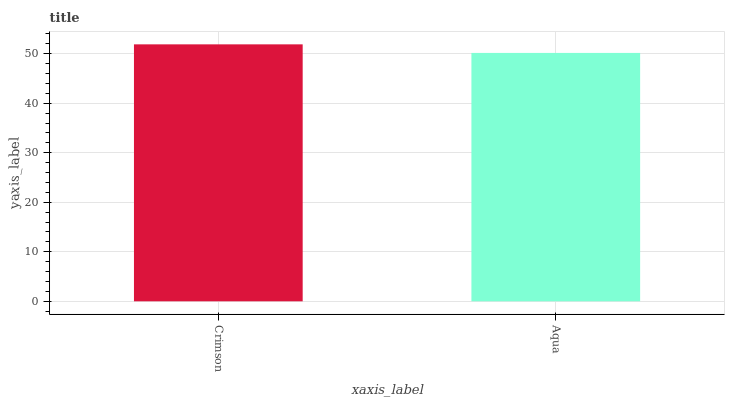Is Aqua the minimum?
Answer yes or no. Yes. Is Crimson the maximum?
Answer yes or no. Yes. Is Aqua the maximum?
Answer yes or no. No. Is Crimson greater than Aqua?
Answer yes or no. Yes. Is Aqua less than Crimson?
Answer yes or no. Yes. Is Aqua greater than Crimson?
Answer yes or no. No. Is Crimson less than Aqua?
Answer yes or no. No. Is Crimson the high median?
Answer yes or no. Yes. Is Aqua the low median?
Answer yes or no. Yes. Is Aqua the high median?
Answer yes or no. No. Is Crimson the low median?
Answer yes or no. No. 